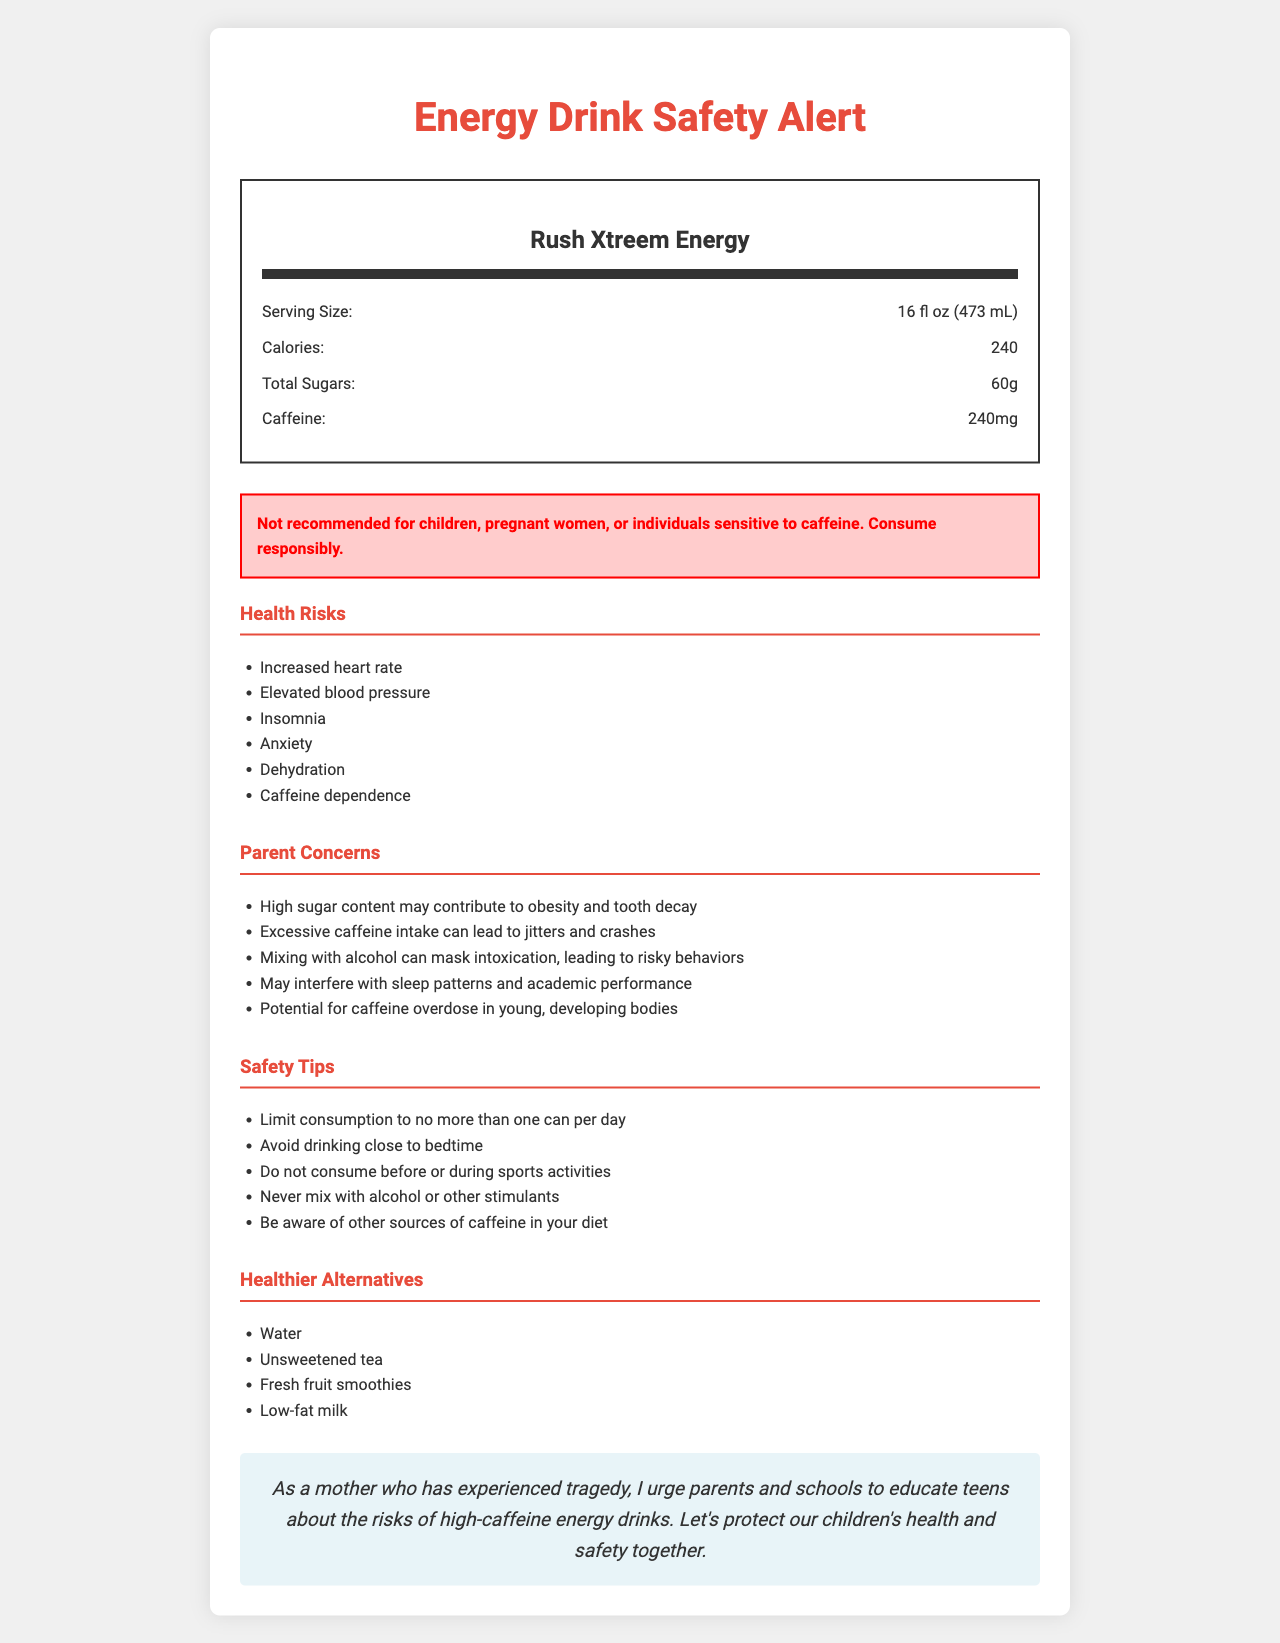What is the serving size of Rush Xtreem Energy? The serving size is explicitly mentioned in the nutrition label section of the document.
Answer: 16 fl oz (473 mL) How much caffeine is in one serving of Rush Xtreem Energy? The caffeine content is listed as 240mg in the nutrition label.
Answer: 240mg What are some health risks associated with consuming Rush Xtreem Energy? These health risks are listed under the 'Health Risks' section.
Answer: Increased heart rate, Elevated blood pressure, Insomnia, Anxiety, Dehydration, Caffeine dependence How much total sugar does Rush Xtreem Energy contain? The total sugar content is specified in the nutrition label section.
Answer: 60g What is the warning given for Rush Xtreem Energy? The warning is clearly stated in the warning box.
Answer: Not recommended for children, pregnant women, or individuals sensitive to caffeine. Consume responsibly. What are some concerns parents might have about Rush Xtreem Energy? A. Contributes to obesity and tooth decay B. Leads to jitters and crashes C. Interferes with sleep patterns D. All of the above All the listed concerns are explicitly mentioned under 'Parent Concerns'.
Answer: D Which of the following is NOT a safety tip mentioned in the document? 1. Limit consumption to no more than one can per day 2. Mix with alcohol for better taste 3. Avoid drinking close to bedtime 4. Never mix with alcohol or other stimulants Mixing with alcohol for better taste is not a safety tip mentioned; in fact, the document advises against mixing with alcohol.
Answer: 2 Can Rush Xtreem Energy be consumed by children? The warning clearly states that it is not recommended for children.
Answer: No Summarize the main message of the document. The document contains detailed information about the ingredients, health risks, and safety tips for Rush Xtreem Energy, aiming to educate and protect the health of teenagers.
Answer: The document informs readers about the nutrition facts and health risks of Rush Xtreem Energy, particularly highlighting the dangers of high caffeine and sugar content in teenagers. It also provides safety tips, lists healthier alternatives, and includes a campaign message urging parents to educate their children about these risks. What is the equivalent unit of the serving size? The document specifies the serving size in fluid ounces and milliliters but does not provide an equivalent in another unit.
Answer: Cannot be determined What are two nutrients provided by Rush Xtreem Energy other than sugar and caffeine? The document lists Vitamin B6 and Vitamin B12 as part of the nutritional components.
Answer: Vitamin B6 and Vitamin B12 